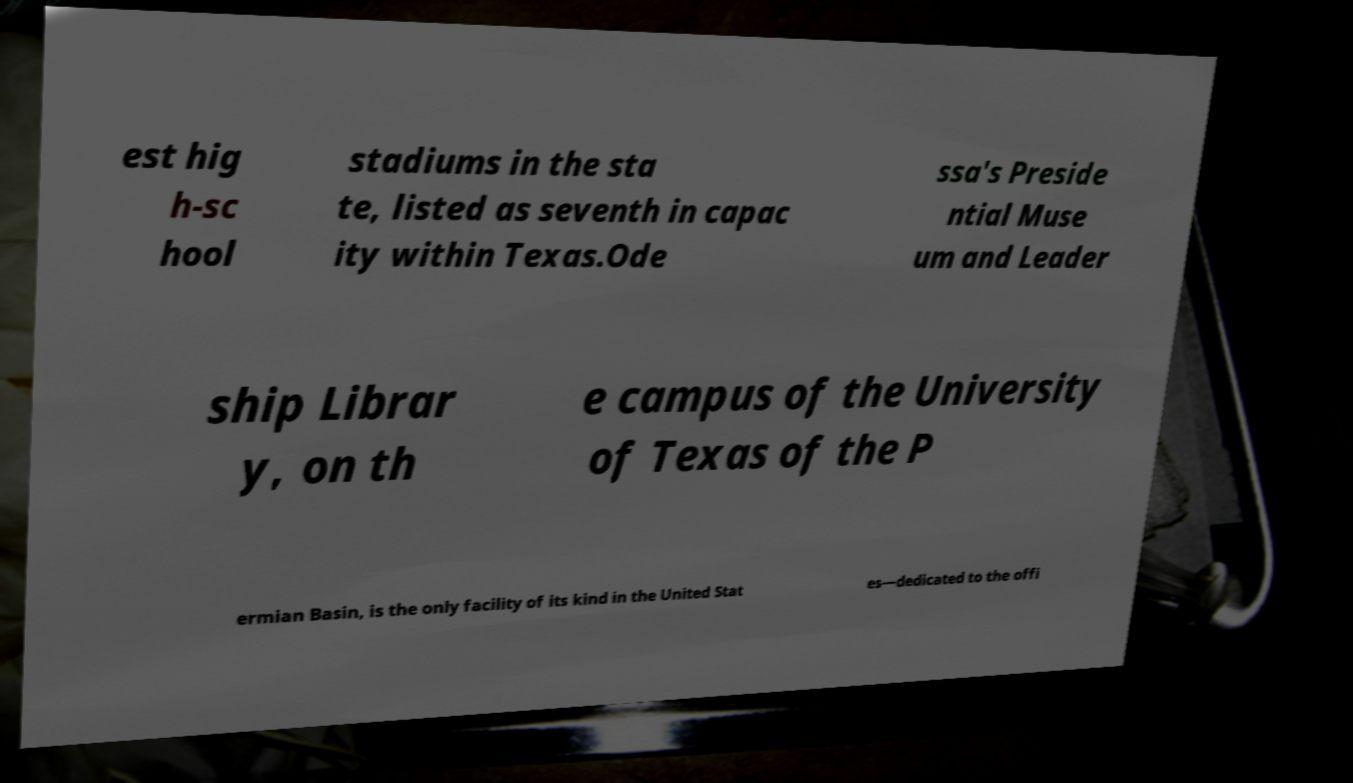I need the written content from this picture converted into text. Can you do that? est hig h-sc hool stadiums in the sta te, listed as seventh in capac ity within Texas.Ode ssa's Preside ntial Muse um and Leader ship Librar y, on th e campus of the University of Texas of the P ermian Basin, is the only facility of its kind in the United Stat es—dedicated to the offi 